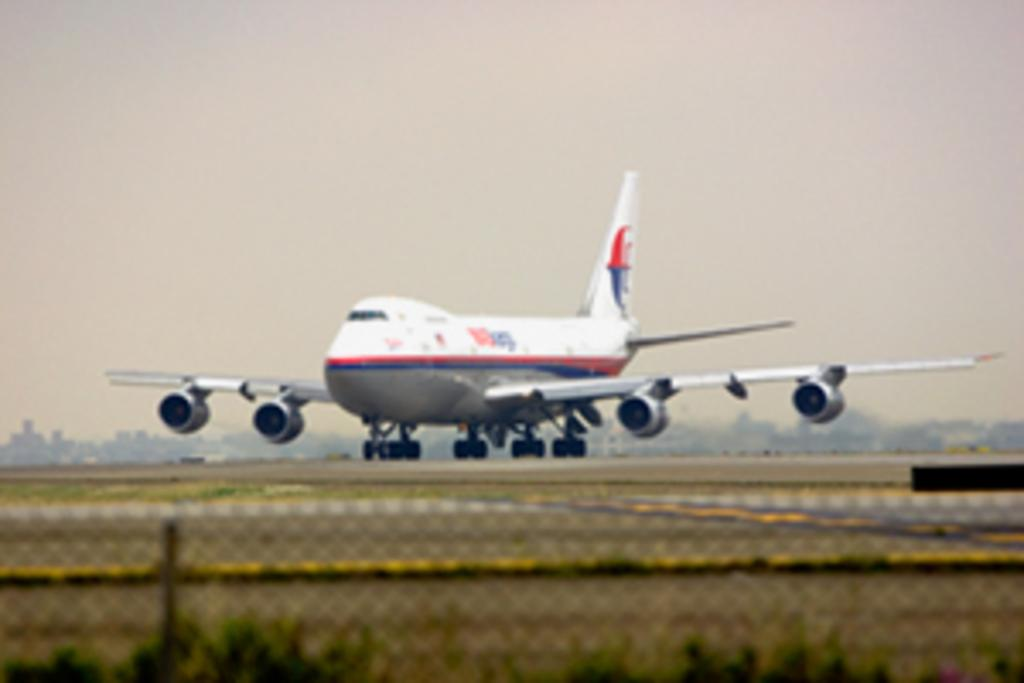What is the main subject in the center of the image? There is an airplane in the center of the image. What can be seen at the bottom of the image? There is a road, plants, and a net at the bottom of the image. What is visible in the background of the image? There are objects in the background of the image. What is visible at the top of the image? The sky is visible at the top of the image. What type of nerve can be seen in the image? There is no nerve present in the image. Can you identify the type of fork used by the passengers in the airplane? There is no fork visible in the image, as it only shows an airplane, a road, plants, a net, objects in the background, and the sky. 